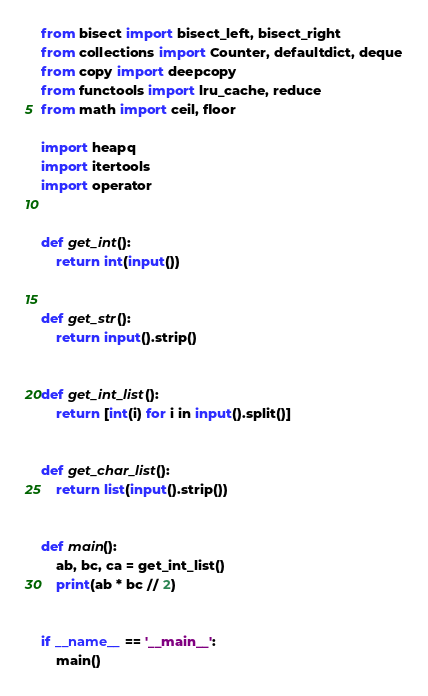Convert code to text. <code><loc_0><loc_0><loc_500><loc_500><_Python_>from bisect import bisect_left, bisect_right
from collections import Counter, defaultdict, deque
from copy import deepcopy
from functools import lru_cache, reduce
from math import ceil, floor

import heapq
import itertools
import operator


def get_int():
    return int(input())


def get_str():
    return input().strip()


def get_int_list():
    return [int(i) for i in input().split()]


def get_char_list():
    return list(input().strip())


def main():
    ab, bc, ca = get_int_list()
    print(ab * bc // 2)


if __name__ == '__main__':
    main()
</code> 